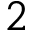<formula> <loc_0><loc_0><loc_500><loc_500>2</formula> 